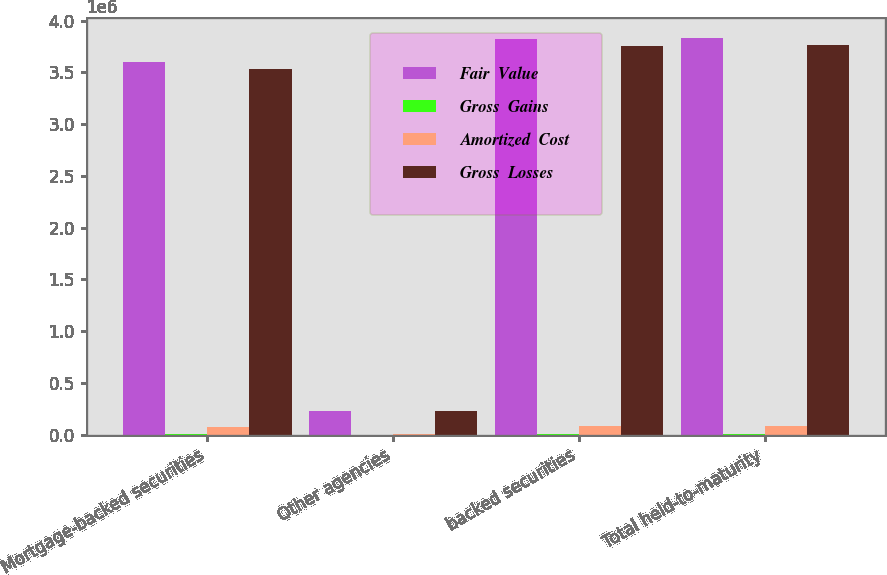Convert chart to OTSL. <chart><loc_0><loc_0><loc_500><loc_500><stacked_bar_chart><ecel><fcel>Mortgage-backed securities<fcel>Other agencies<fcel>backed securities<fcel>Total held-to-maturity<nl><fcel>Fair  Value<fcel>3.59906e+06<fcel>228587<fcel>3.82764e+06<fcel>3.83667e+06<nl><fcel>Gross  Gains<fcel>5573<fcel>776<fcel>6349<fcel>6349<nl><fcel>Amortized  Cost<fcel>76063<fcel>5191<fcel>81254<fcel>82118<nl><fcel>Gross  Losses<fcel>3.52857e+06<fcel>224172<fcel>3.75274e+06<fcel>3.7609e+06<nl></chart> 